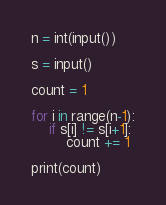<code> <loc_0><loc_0><loc_500><loc_500><_Python_>n = int(input())

s = input()

count = 1

for i in range(n-1):
    if s[i] != s[i+1]:
        count += 1

print(count)</code> 